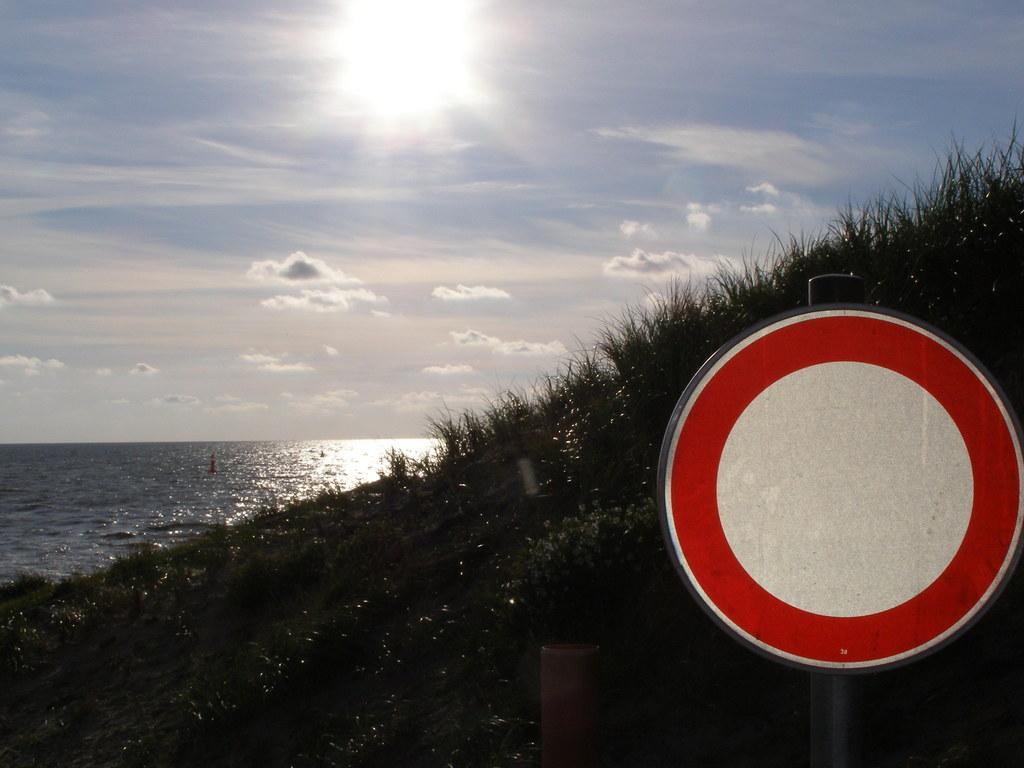How would you summarize this image in a sentence or two? In this image I can see the board attached to the board and the board is in white and red color. In the background I can see the grass and I can also see the water and the sky is in blue and white color. 